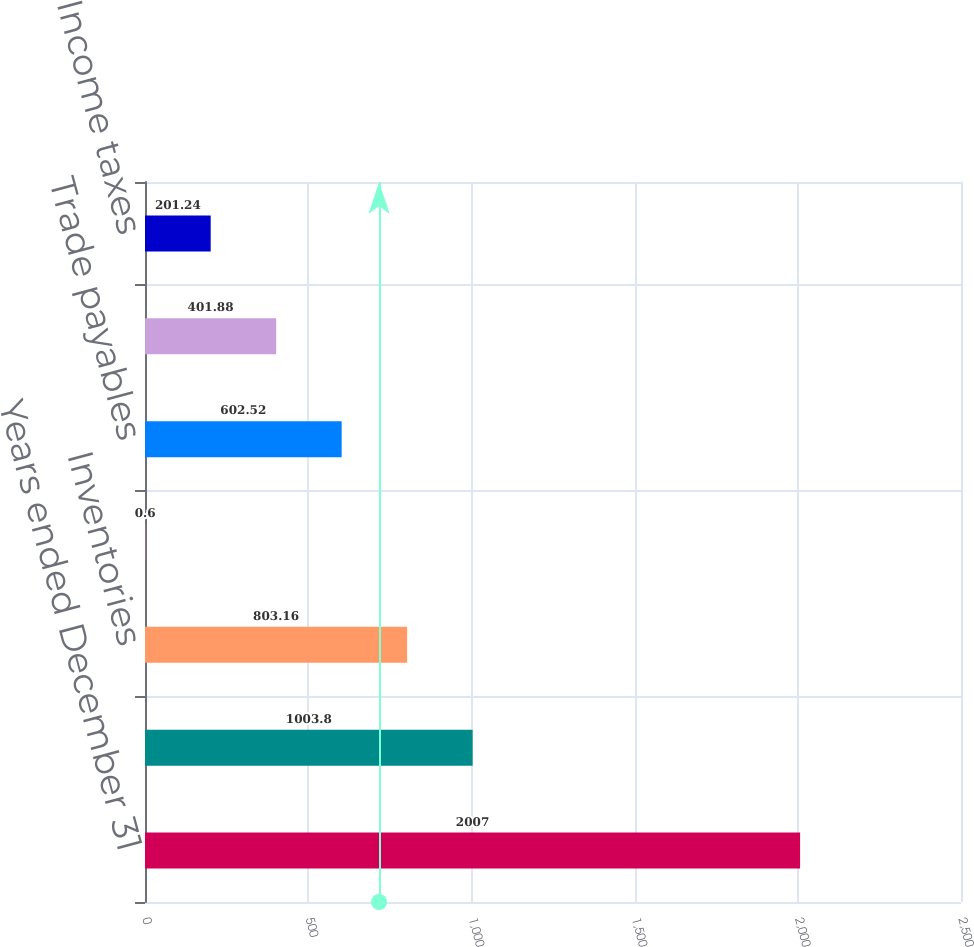Convert chart. <chart><loc_0><loc_0><loc_500><loc_500><bar_chart><fcel>Years ended December 31<fcel>Receivables<fcel>Inventories<fcel>Other current assets<fcel>Trade payables<fcel>Accrued liabilities including<fcel>Income taxes<nl><fcel>2007<fcel>1003.8<fcel>803.16<fcel>0.6<fcel>602.52<fcel>401.88<fcel>201.24<nl></chart> 